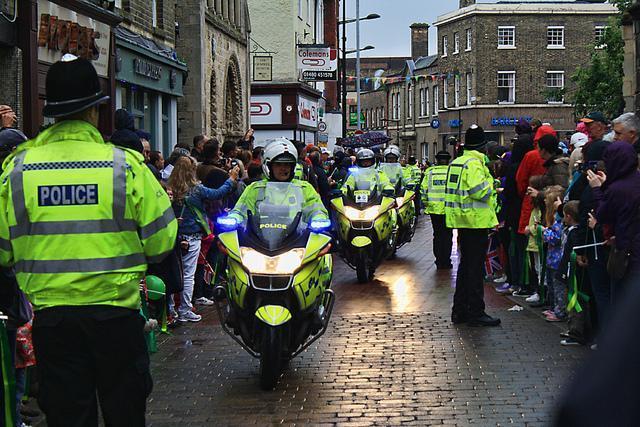How many police are on horses?
Give a very brief answer. 0. How many people are in the picture?
Give a very brief answer. 9. How many motorcycles can you see?
Give a very brief answer. 2. 